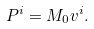Convert formula to latex. <formula><loc_0><loc_0><loc_500><loc_500>P ^ { i } = M _ { 0 } v ^ { i } .</formula> 